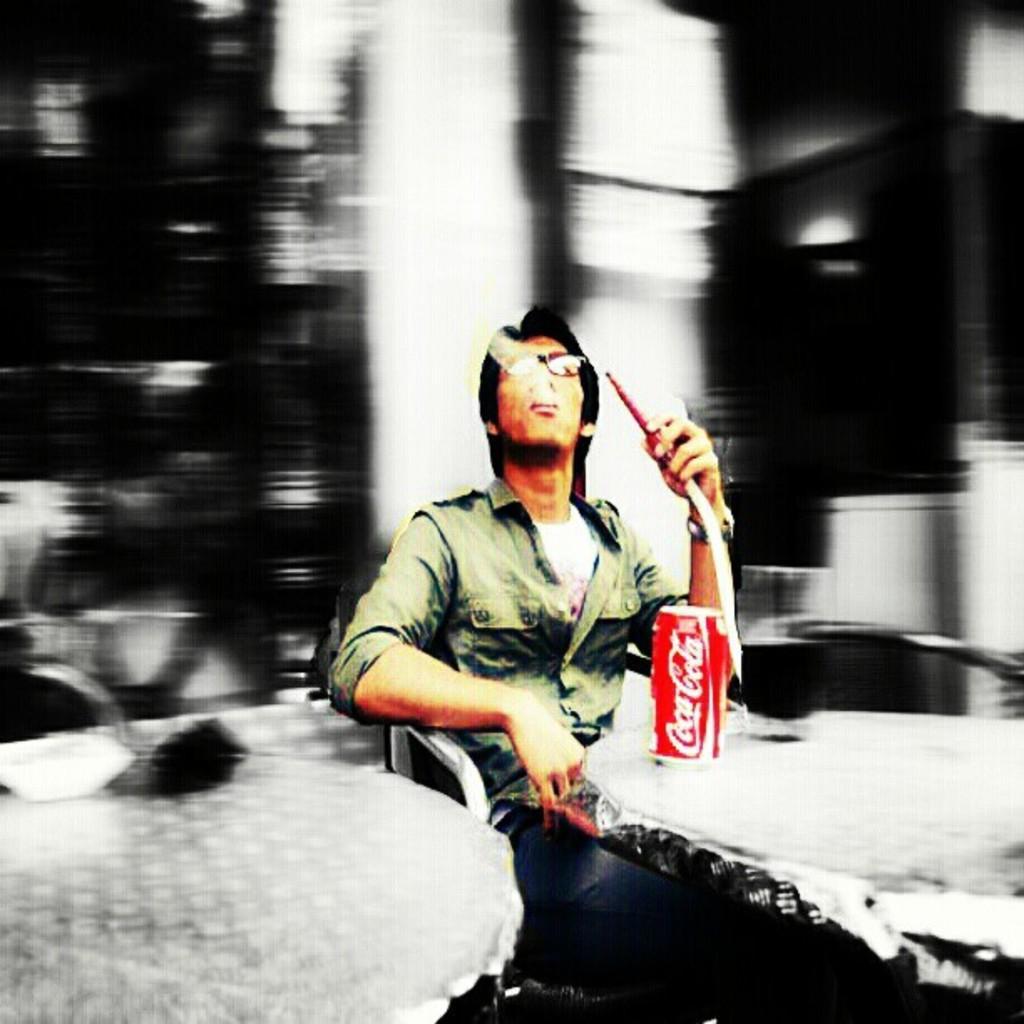In one or two sentences, can you explain what this image depicts? In this image I can see the person with the dress and the person is holding the pipe. In-front of the person I can see the tin on the table. 